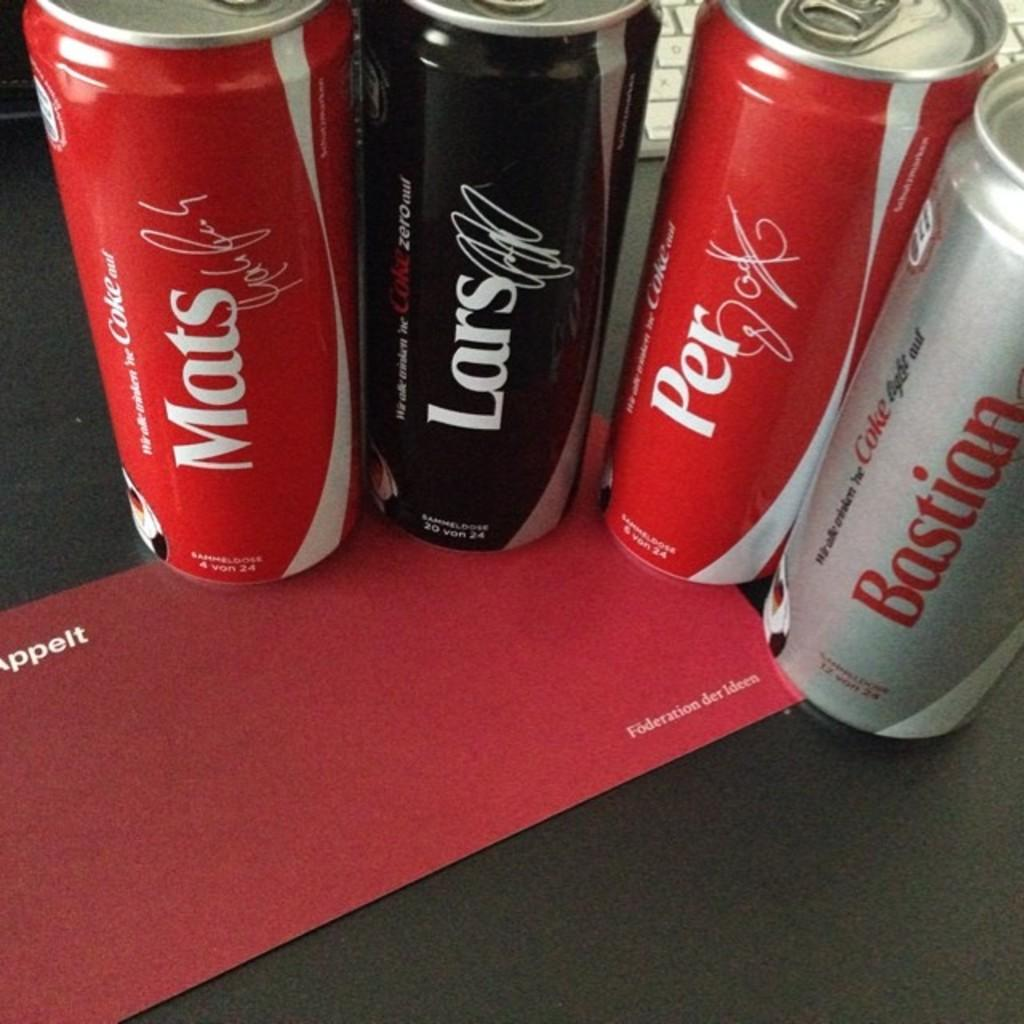<image>
Offer a succinct explanation of the picture presented. Several different cans of coke with different names on them including Bastian. 